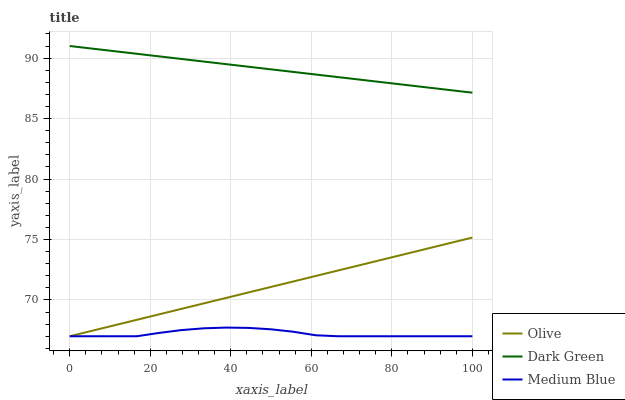Does Medium Blue have the minimum area under the curve?
Answer yes or no. Yes. Does Dark Green have the maximum area under the curve?
Answer yes or no. Yes. Does Dark Green have the minimum area under the curve?
Answer yes or no. No. Does Medium Blue have the maximum area under the curve?
Answer yes or no. No. Is Dark Green the smoothest?
Answer yes or no. Yes. Is Medium Blue the roughest?
Answer yes or no. Yes. Is Medium Blue the smoothest?
Answer yes or no. No. Is Dark Green the roughest?
Answer yes or no. No. Does Olive have the lowest value?
Answer yes or no. Yes. Does Dark Green have the lowest value?
Answer yes or no. No. Does Dark Green have the highest value?
Answer yes or no. Yes. Does Medium Blue have the highest value?
Answer yes or no. No. Is Medium Blue less than Dark Green?
Answer yes or no. Yes. Is Dark Green greater than Medium Blue?
Answer yes or no. Yes. Does Olive intersect Medium Blue?
Answer yes or no. Yes. Is Olive less than Medium Blue?
Answer yes or no. No. Is Olive greater than Medium Blue?
Answer yes or no. No. Does Medium Blue intersect Dark Green?
Answer yes or no. No. 